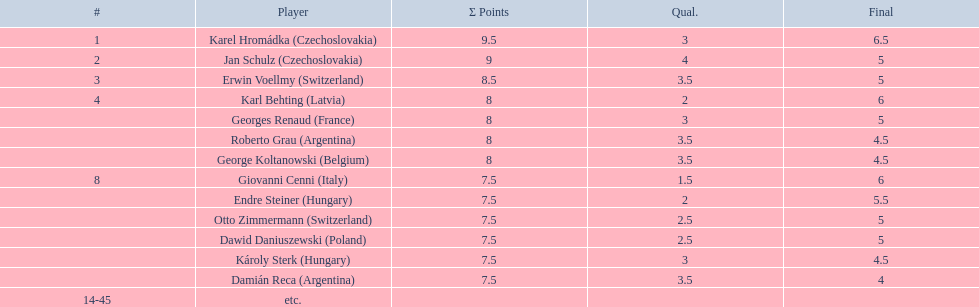How many players achieved 8 points? 4. 